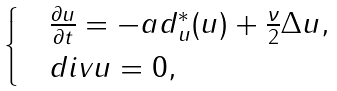Convert formula to latex. <formula><loc_0><loc_0><loc_500><loc_500>\begin{cases} & \frac { \partial u } { \partial t } = - a d ^ { * } _ { u } ( u ) + \frac { \nu } { 2 } \Delta u , \\ & d i v u = 0 , \end{cases}</formula> 